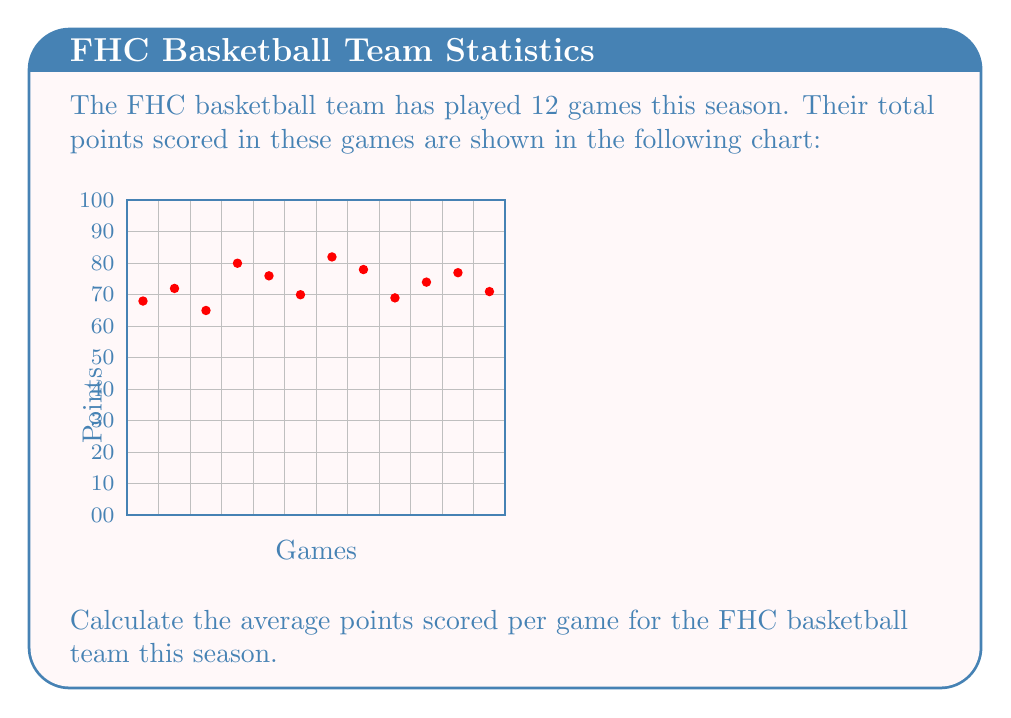Provide a solution to this math problem. To calculate the average points scored per game, we need to:

1. Find the total points scored across all games
2. Divide the total points by the number of games

Step 1: Sum up the points from all games
$68 + 72 + 65 + 80 + 76 + 70 + 82 + 78 + 69 + 74 + 77 + 71 = 882$ points

Step 2: Divide the total points by the number of games
Number of games = 12

Average points per game = $\frac{\text{Total points}}{\text{Number of games}}$

$$\text{Average} = \frac{882}{12} = 73.5$$

Therefore, the FHC basketball team scored an average of 73.5 points per game this season.
Answer: $73.5$ points per game 